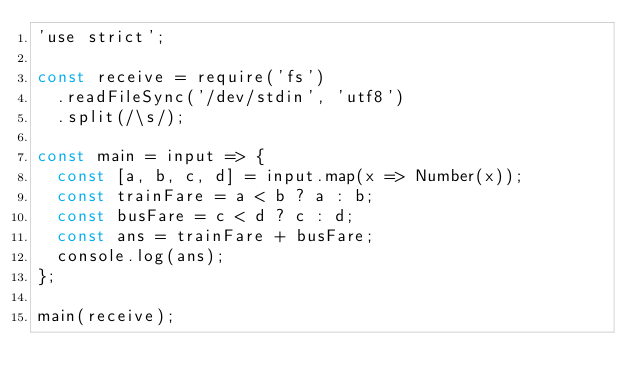<code> <loc_0><loc_0><loc_500><loc_500><_JavaScript_>'use strict';

const receive = require('fs')
  .readFileSync('/dev/stdin', 'utf8')
  .split(/\s/);

const main = input => {
  const [a, b, c, d] = input.map(x => Number(x));
  const trainFare = a < b ? a : b;
  const busFare = c < d ? c : d;
  const ans = trainFare + busFare;
  console.log(ans);
};

main(receive);</code> 